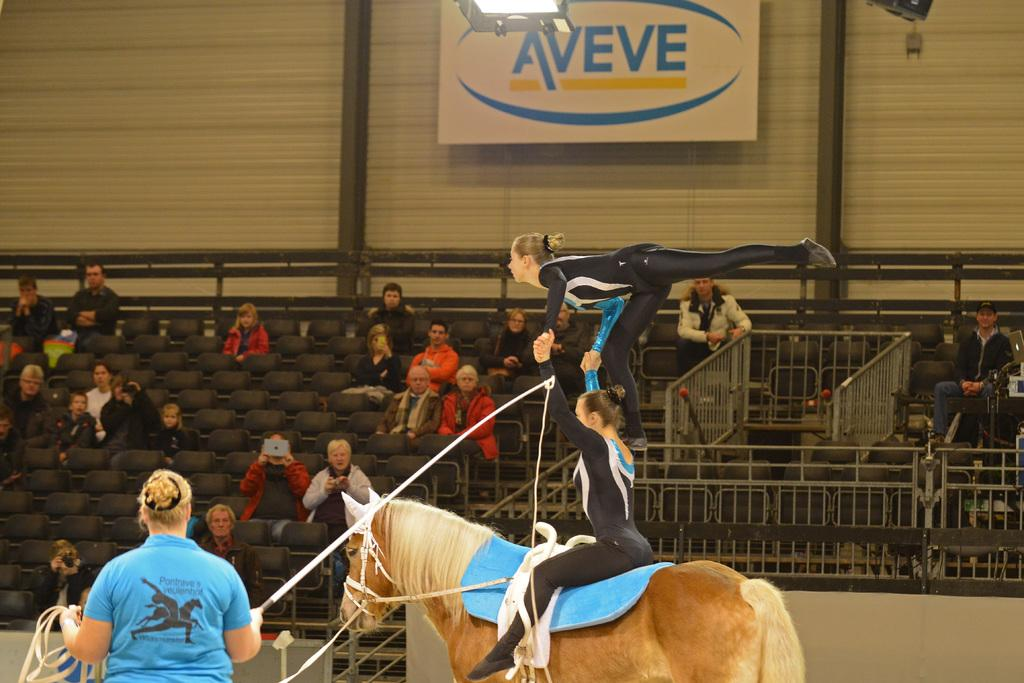How many people are in the image? There is a group of people in the image. What are the people doing in the image? The people are sitting on a chair. What other animal or object is present in the image? There is a horse in the image. Who is sitting on the horse? A woman is sitting on the horse. How many brothers are visible in the image? There is no mention of brothers in the image, so we cannot determine their presence or number. 